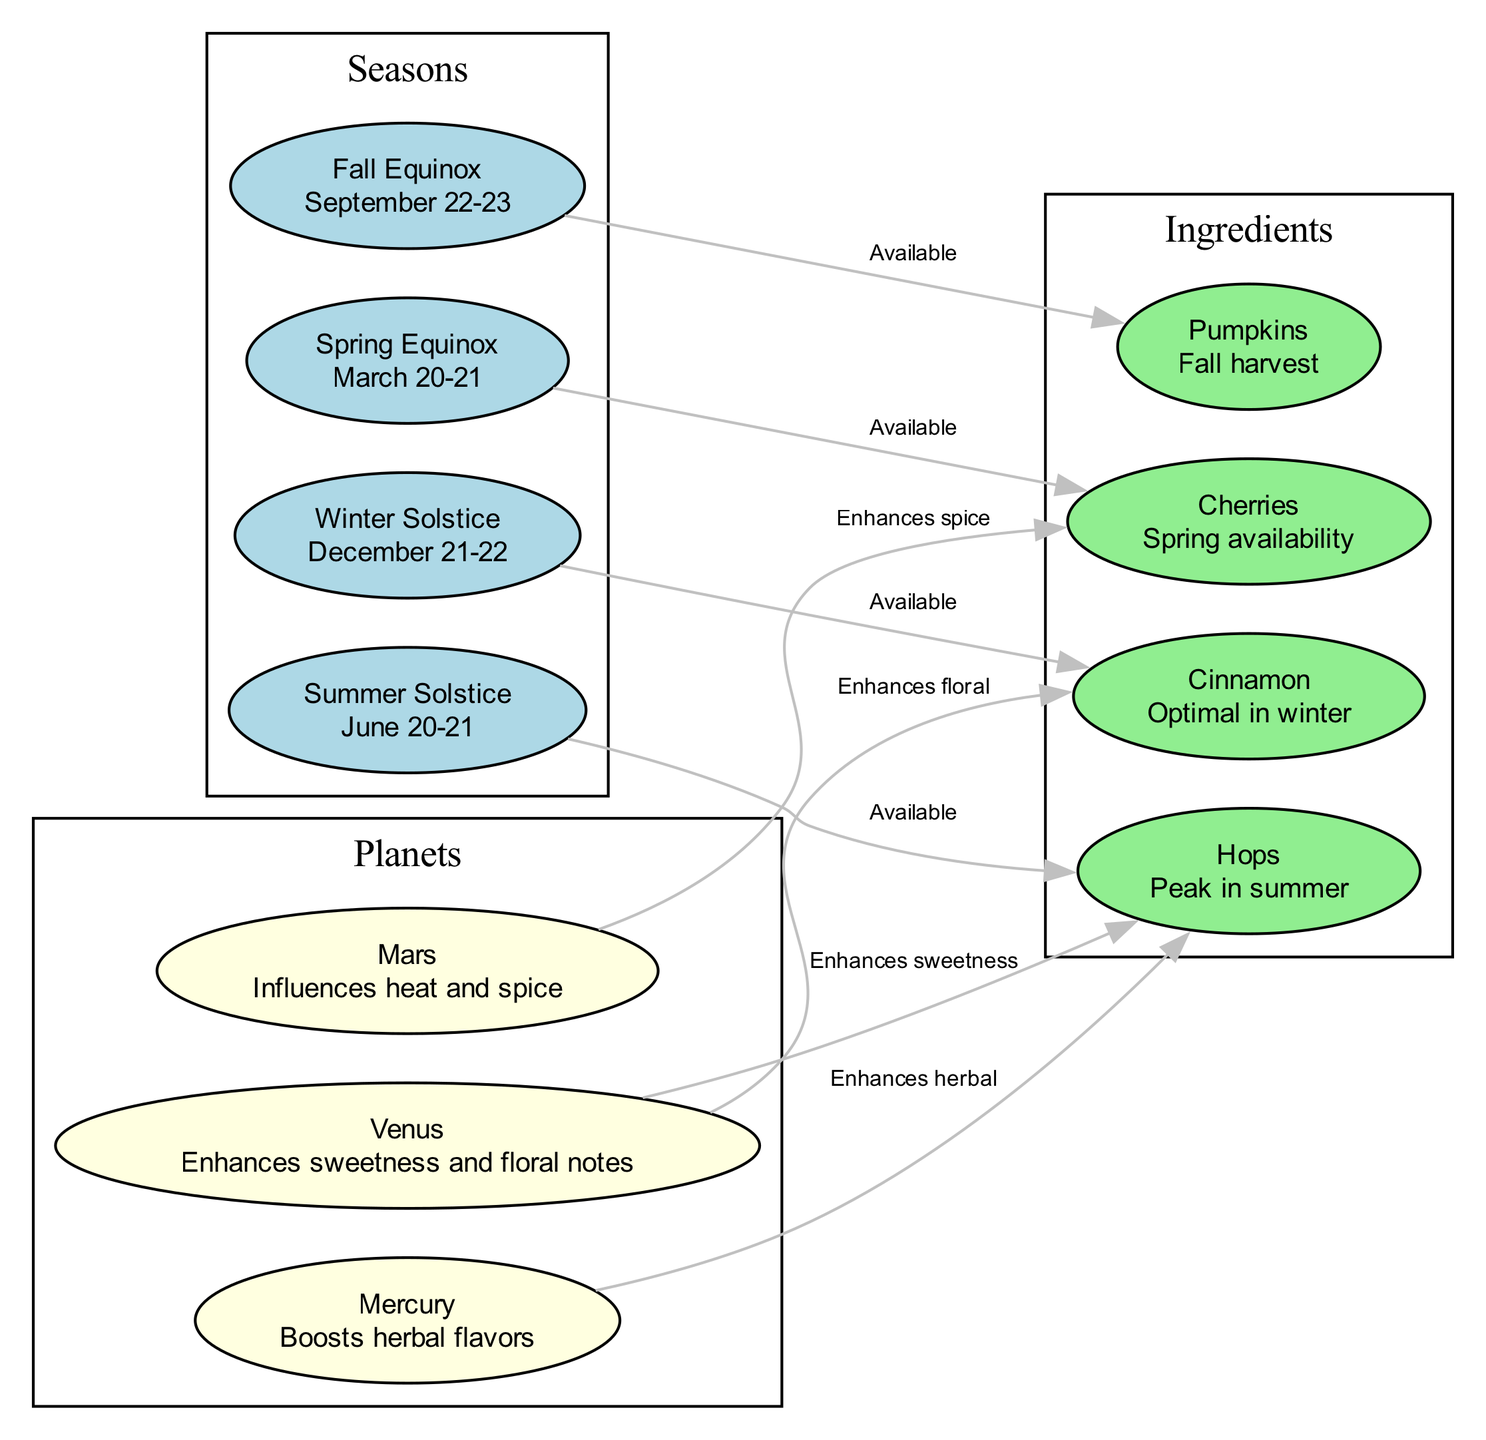What node represents the equinox in spring? The diagram shows a node labeled "Spring Equinox," specifically noting the date range March 20-21. This is clearly indicated as the seasonal milestone for spring.
Answer: Spring Equinox How many seasonal nodes are present in the diagram? The diagram contains four nodes dedicated to the seasons: Spring Equinox, Summer Solstice, Fall Equinox, and Winter Solstice. Thus, we count four seasonal nodes.
Answer: 4 Which ingredient is available during the Summer Solstice? The diagram displays an edge from the Summer Solstice node to the Hops ingredient node, indicating that Hops are available during this time.
Answer: Hops What does Venus enhance according to the diagram? The diagram illustrates an edge from the Venus node to the Hops node and another to the Cinnamon node. This indicates that Venus enhances sweetness and floral notes in these ingredients.
Answer: Sweetness, floral What is the relationship between Mars and Cherries? There is an edge connecting Mars to the Cherries node, labeled "Enhances spice." This shows that Mars influences the spiciness associated with cherries.
Answer: Enhances spice Which ingredient is associated with the Winter Solstice? The diagram leads from the Winter Solstice node to the Cinnamon node, indicating that Cinnamon is the ingredient associated with the Winter Solstice season.
Answer: Cinnamon Which planet enhances herbal flavors? An edge links the Mercury node to the Hops node, which specifies that Mercury boosts herbal flavors in the context of this diagram.
Answer: Mercury Describe the seasonal availability of Pumpkins. The diagram shows an edge from the Fall Equinox node to the Pumpkins node, labeled "Available." This indicates that Pumpkins are available for harvest during the fall season.
Answer: Fall Equinox How many edges connect planets to ingredients in this diagram? By counting the edges, we find that there are four edges connecting planets (Mars, Venus, Mercury) to their respective ingredients (Cherries, Hops, Cinnamon). Hence, this means there are four connections.
Answer: 4 